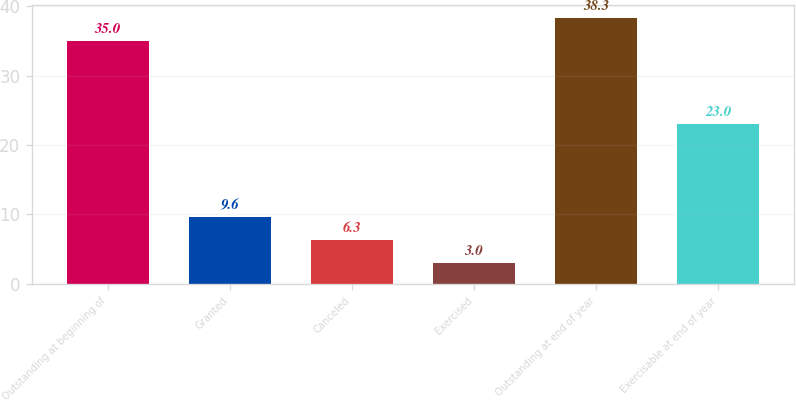Convert chart. <chart><loc_0><loc_0><loc_500><loc_500><bar_chart><fcel>Outstanding at beginning of<fcel>Granted<fcel>Canceled<fcel>Exercised<fcel>Outstanding at end of year<fcel>Exercisable at end of year<nl><fcel>35<fcel>9.6<fcel>6.3<fcel>3<fcel>38.3<fcel>23<nl></chart> 